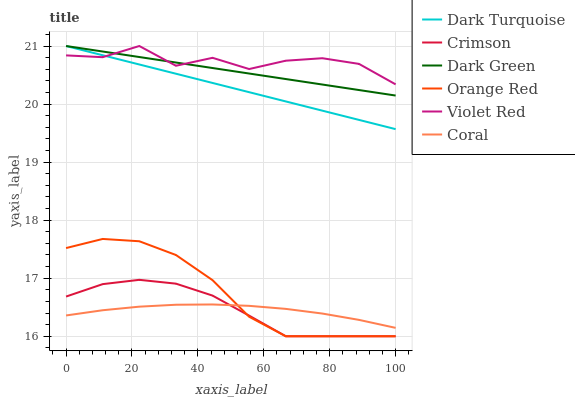Does Dark Turquoise have the minimum area under the curve?
Answer yes or no. No. Does Dark Turquoise have the maximum area under the curve?
Answer yes or no. No. Is Dark Turquoise the smoothest?
Answer yes or no. No. Is Dark Turquoise the roughest?
Answer yes or no. No. Does Dark Turquoise have the lowest value?
Answer yes or no. No. Does Coral have the highest value?
Answer yes or no. No. Is Orange Red less than Violet Red?
Answer yes or no. Yes. Is Dark Turquoise greater than Crimson?
Answer yes or no. Yes. Does Orange Red intersect Violet Red?
Answer yes or no. No. 